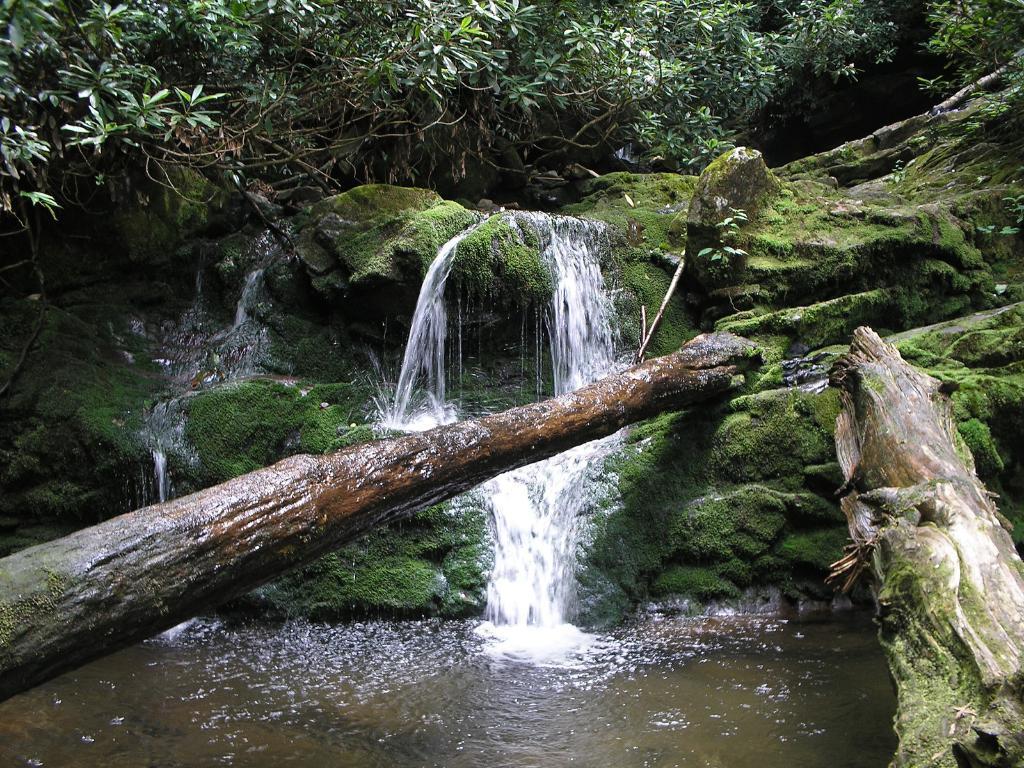Can you describe this image briefly? In this picture we can see tree trunks, water, grass and in the background we can see trees. 